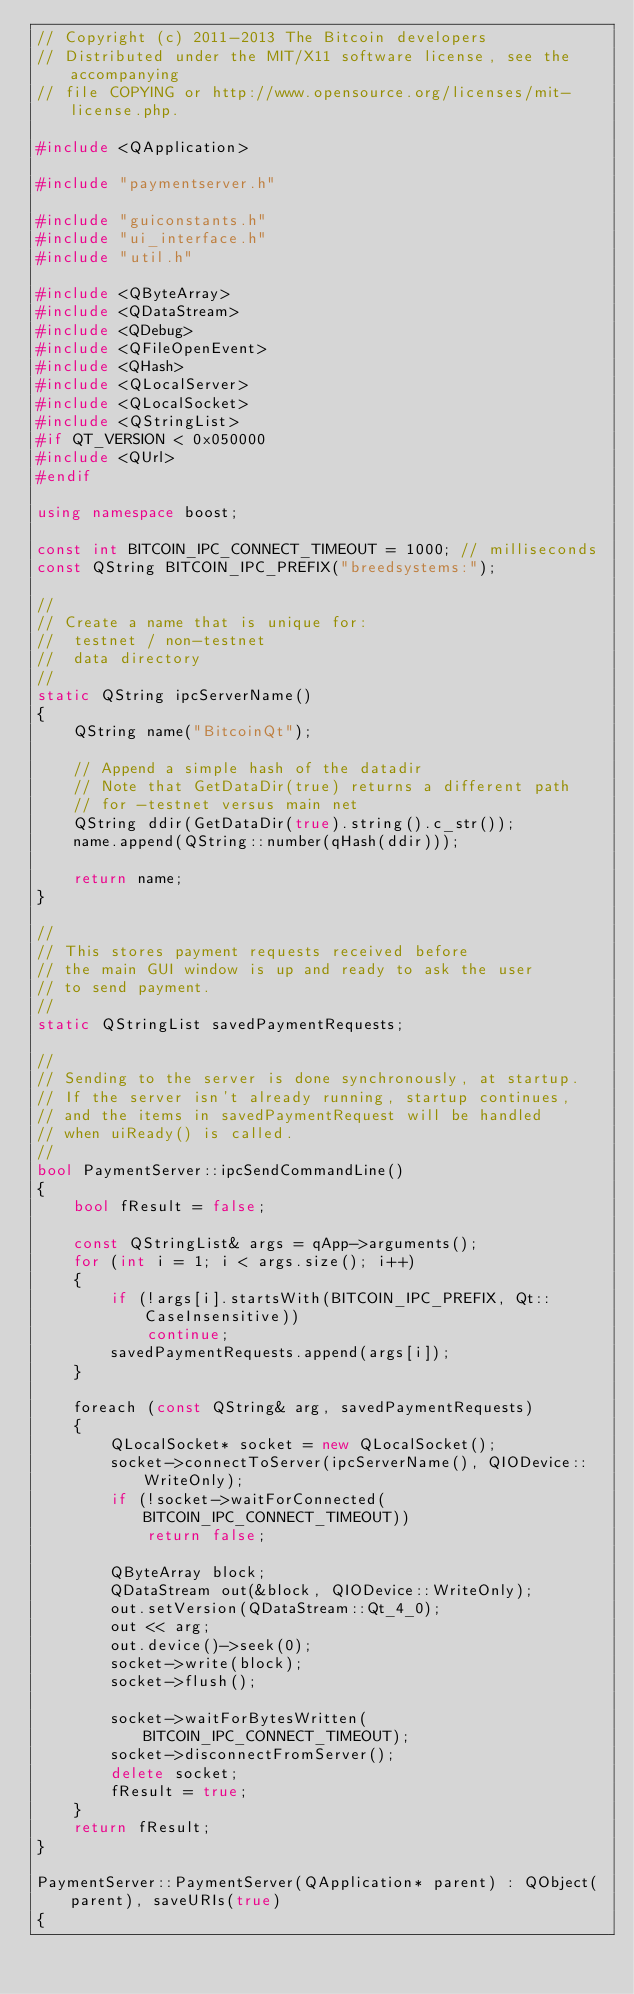<code> <loc_0><loc_0><loc_500><loc_500><_C++_>// Copyright (c) 2011-2013 The Bitcoin developers
// Distributed under the MIT/X11 software license, see the accompanying
// file COPYING or http://www.opensource.org/licenses/mit-license.php.

#include <QApplication>

#include "paymentserver.h"

#include "guiconstants.h"
#include "ui_interface.h"
#include "util.h"

#include <QByteArray>
#include <QDataStream>
#include <QDebug>
#include <QFileOpenEvent>
#include <QHash>
#include <QLocalServer>
#include <QLocalSocket>
#include <QStringList>
#if QT_VERSION < 0x050000
#include <QUrl>
#endif

using namespace boost;

const int BITCOIN_IPC_CONNECT_TIMEOUT = 1000; // milliseconds
const QString BITCOIN_IPC_PREFIX("breedsystems:");

//
// Create a name that is unique for:
//  testnet / non-testnet
//  data directory
//
static QString ipcServerName()
{
    QString name("BitcoinQt");

    // Append a simple hash of the datadir
    // Note that GetDataDir(true) returns a different path
    // for -testnet versus main net
    QString ddir(GetDataDir(true).string().c_str());
    name.append(QString::number(qHash(ddir)));

    return name;
}

//
// This stores payment requests received before
// the main GUI window is up and ready to ask the user
// to send payment.
//
static QStringList savedPaymentRequests;

//
// Sending to the server is done synchronously, at startup.
// If the server isn't already running, startup continues,
// and the items in savedPaymentRequest will be handled
// when uiReady() is called.
//
bool PaymentServer::ipcSendCommandLine()
{
    bool fResult = false;

    const QStringList& args = qApp->arguments();
    for (int i = 1; i < args.size(); i++)
    {
        if (!args[i].startsWith(BITCOIN_IPC_PREFIX, Qt::CaseInsensitive))
            continue;
        savedPaymentRequests.append(args[i]);
    }

    foreach (const QString& arg, savedPaymentRequests)
    {
        QLocalSocket* socket = new QLocalSocket();
        socket->connectToServer(ipcServerName(), QIODevice::WriteOnly);
        if (!socket->waitForConnected(BITCOIN_IPC_CONNECT_TIMEOUT))
            return false;

        QByteArray block;
        QDataStream out(&block, QIODevice::WriteOnly);
        out.setVersion(QDataStream::Qt_4_0);
        out << arg;
        out.device()->seek(0);
        socket->write(block);
        socket->flush();

        socket->waitForBytesWritten(BITCOIN_IPC_CONNECT_TIMEOUT);
        socket->disconnectFromServer();
        delete socket;
        fResult = true;
    }
    return fResult;
}

PaymentServer::PaymentServer(QApplication* parent) : QObject(parent), saveURIs(true)
{</code> 